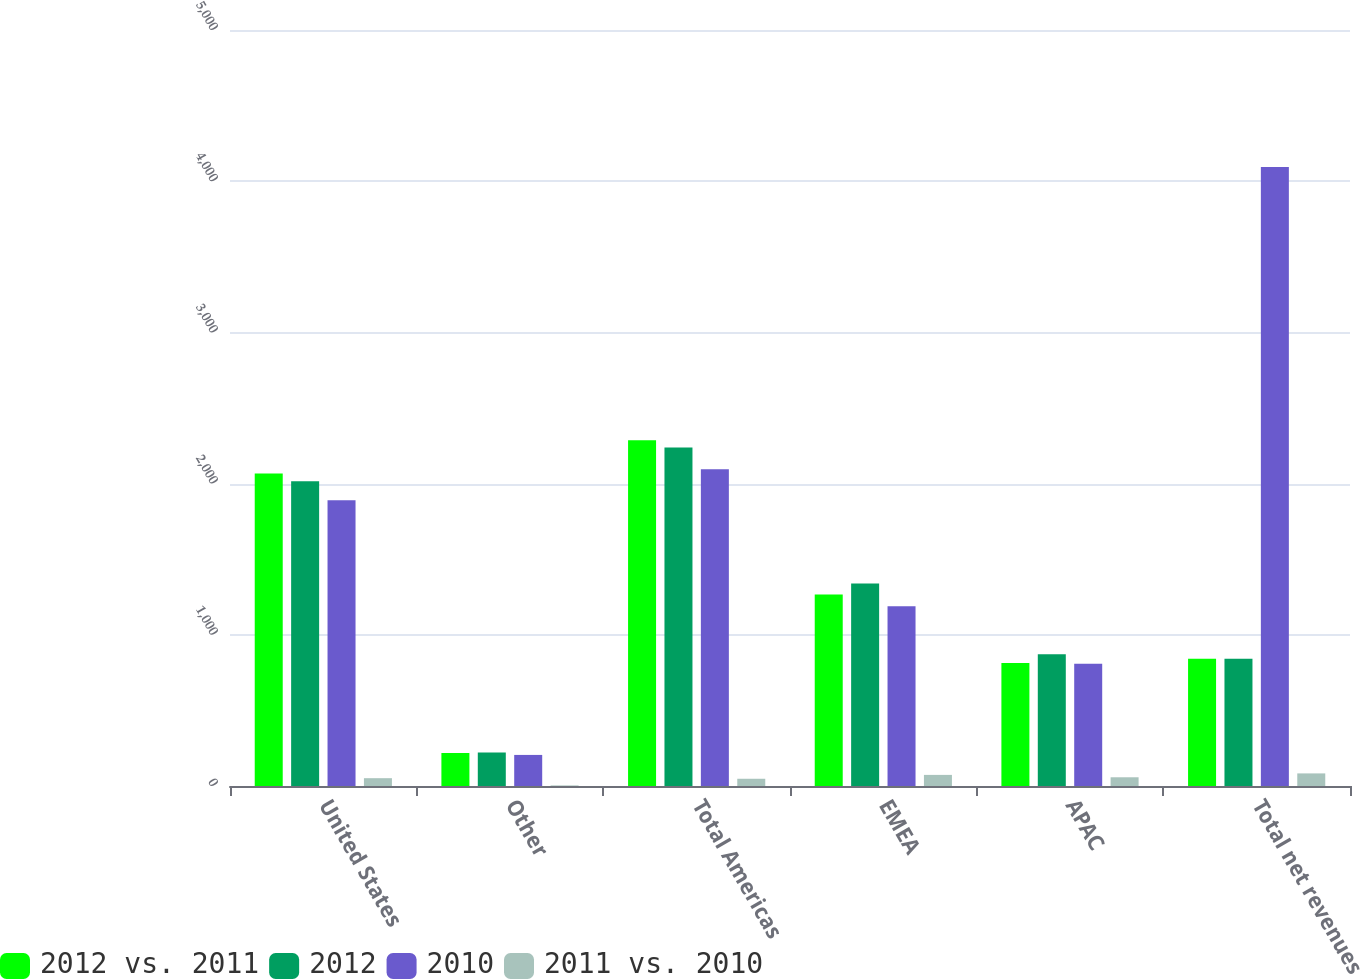Convert chart. <chart><loc_0><loc_0><loc_500><loc_500><stacked_bar_chart><ecel><fcel>United States<fcel>Other<fcel>Total Americas<fcel>EMEA<fcel>APAC<fcel>Total net revenues<nl><fcel>2012 vs. 2011<fcel>2067.5<fcel>218.4<fcel>2285.9<fcel>1266.3<fcel>813.2<fcel>842.05<nl><fcel>2012<fcel>2015.8<fcel>222.2<fcel>2238<fcel>1339.8<fcel>870.9<fcel>842.05<nl><fcel>2010<fcel>1890.1<fcel>205.5<fcel>2095.6<fcel>1189.3<fcel>808.4<fcel>4093.3<nl><fcel>2011 vs. 2010<fcel>51.7<fcel>3.8<fcel>47.9<fcel>73.5<fcel>57.7<fcel>83.3<nl></chart> 